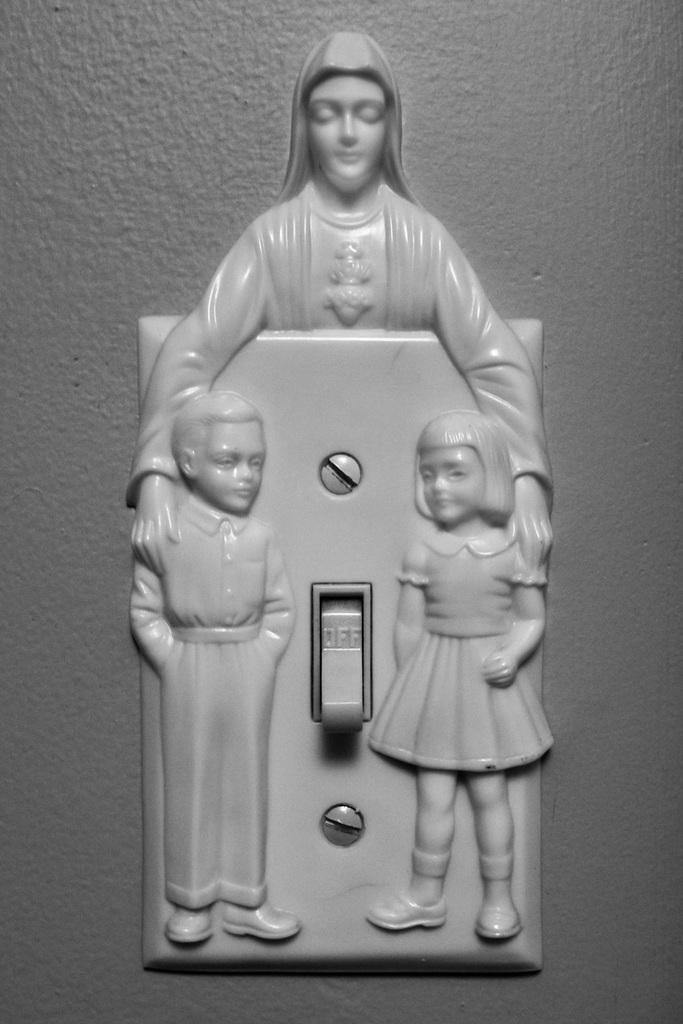Could you give a brief overview of what you see in this image? In this image, we can see a switch board with sculptures is placed on the wall. 